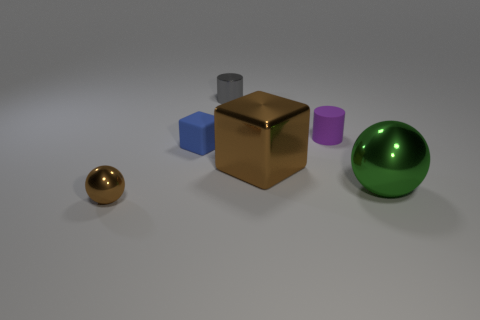Add 3 blue cubes. How many objects exist? 9 Subtract all cylinders. How many objects are left? 4 Subtract all metallic things. Subtract all purple cylinders. How many objects are left? 1 Add 2 purple objects. How many purple objects are left? 3 Add 1 tiny gray cylinders. How many tiny gray cylinders exist? 2 Subtract 0 yellow cylinders. How many objects are left? 6 Subtract all green blocks. Subtract all blue balls. How many blocks are left? 2 